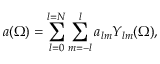<formula> <loc_0><loc_0><loc_500><loc_500>a ( \Omega ) = \sum _ { l = 0 } ^ { l = N } \sum _ { m = - l } ^ { l } a _ { l m } Y _ { l m } ( \Omega ) ,</formula> 